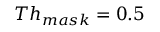Convert formula to latex. <formula><loc_0><loc_0><loc_500><loc_500>T h _ { m a s k } = 0 . 5</formula> 